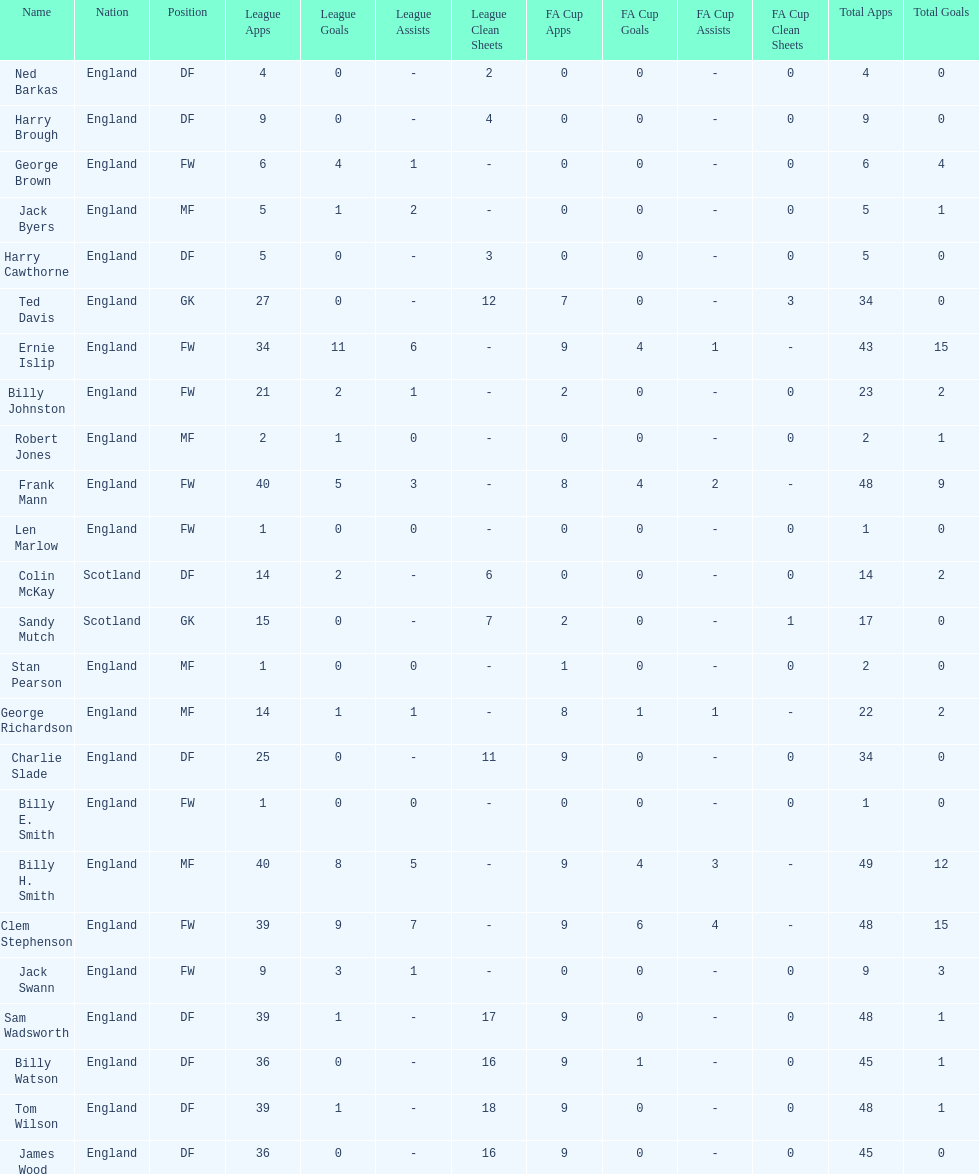What are the number of league apps ted davis has? 27. 